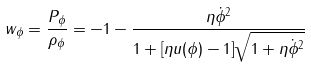<formula> <loc_0><loc_0><loc_500><loc_500>w _ { \phi } = \frac { P _ { \phi } } { \rho _ { \phi } } = - 1 - \frac { \eta \dot { \phi } ^ { 2 } } { 1 + [ \eta u ( \phi ) - 1 ] \sqrt { 1 + \eta \dot { \phi } ^ { 2 } } }</formula> 